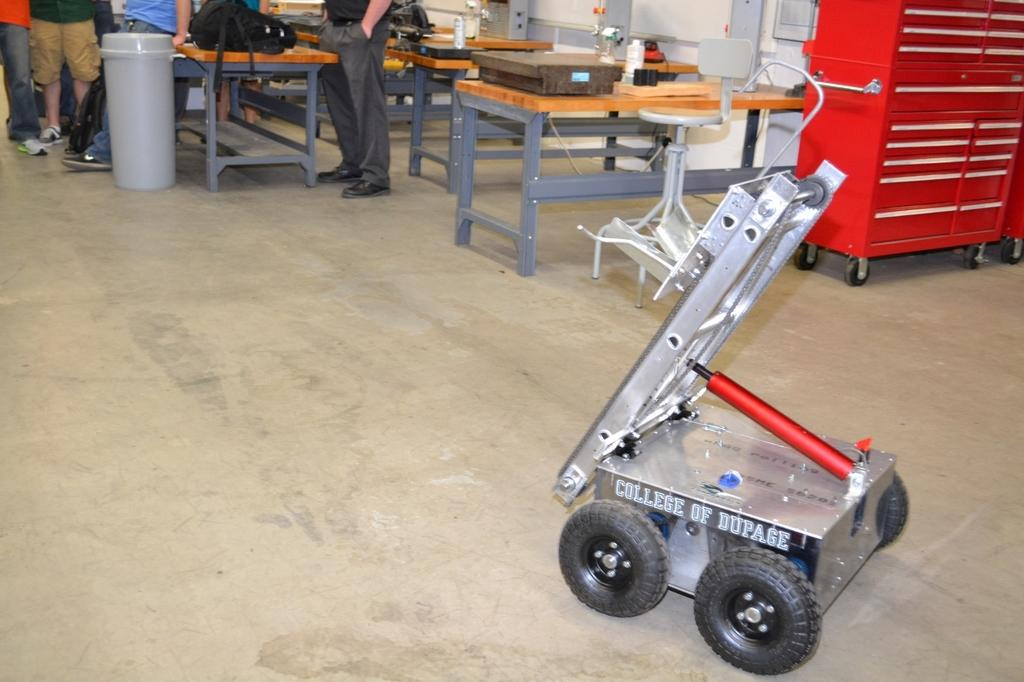What is the main object in the image? There is a machine in the image. What can be seen in the background of the image? There are tables, a container, and people standing in the background of the image. What type of linen is being used to heat the machine in the image? There is no linen or heating element present in the image; it only shows a machine and objects in the background. 